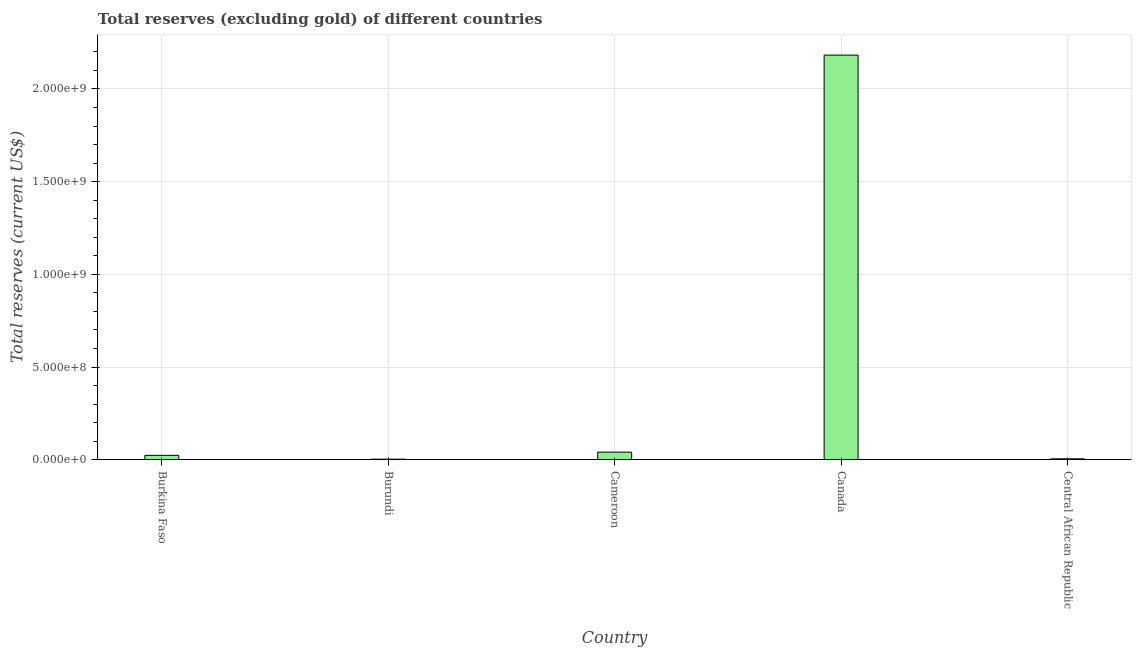Does the graph contain any zero values?
Your response must be concise. No. Does the graph contain grids?
Make the answer very short. Yes. What is the title of the graph?
Your response must be concise. Total reserves (excluding gold) of different countries. What is the label or title of the X-axis?
Offer a very short reply. Country. What is the label or title of the Y-axis?
Ensure brevity in your answer.  Total reserves (current US$). What is the total reserves (excluding gold) in Central African Republic?
Provide a short and direct response. 4.70e+06. Across all countries, what is the maximum total reserves (excluding gold)?
Provide a short and direct response. 2.18e+09. Across all countries, what is the minimum total reserves (excluding gold)?
Keep it short and to the point. 2.91e+06. In which country was the total reserves (excluding gold) maximum?
Keep it short and to the point. Canada. In which country was the total reserves (excluding gold) minimum?
Your answer should be compact. Burundi. What is the sum of the total reserves (excluding gold)?
Make the answer very short. 2.25e+09. What is the difference between the total reserves (excluding gold) in Burkina Faso and Canada?
Your answer should be compact. -2.16e+09. What is the average total reserves (excluding gold) per country?
Ensure brevity in your answer.  4.51e+08. What is the median total reserves (excluding gold)?
Offer a very short reply. 2.34e+07. In how many countries, is the total reserves (excluding gold) greater than 2100000000 US$?
Provide a succinct answer. 1. What is the ratio of the total reserves (excluding gold) in Burkina Faso to that in Burundi?
Your response must be concise. 8.05. Is the total reserves (excluding gold) in Cameroon less than that in Central African Republic?
Provide a short and direct response. No. What is the difference between the highest and the second highest total reserves (excluding gold)?
Make the answer very short. 2.14e+09. Is the sum of the total reserves (excluding gold) in Cameroon and Central African Republic greater than the maximum total reserves (excluding gold) across all countries?
Ensure brevity in your answer.  No. What is the difference between the highest and the lowest total reserves (excluding gold)?
Ensure brevity in your answer.  2.18e+09. What is the difference between two consecutive major ticks on the Y-axis?
Ensure brevity in your answer.  5.00e+08. What is the Total reserves (current US$) of Burkina Faso?
Ensure brevity in your answer.  2.34e+07. What is the Total reserves (current US$) in Burundi?
Offer a very short reply. 2.91e+06. What is the Total reserves (current US$) in Cameroon?
Keep it short and to the point. 4.09e+07. What is the Total reserves (current US$) in Canada?
Your response must be concise. 2.18e+09. What is the Total reserves (current US$) of Central African Republic?
Make the answer very short. 4.70e+06. What is the difference between the Total reserves (current US$) in Burkina Faso and Burundi?
Keep it short and to the point. 2.05e+07. What is the difference between the Total reserves (current US$) in Burkina Faso and Cameroon?
Keep it short and to the point. -1.74e+07. What is the difference between the Total reserves (current US$) in Burkina Faso and Canada?
Your answer should be very brief. -2.16e+09. What is the difference between the Total reserves (current US$) in Burkina Faso and Central African Republic?
Your answer should be very brief. 1.87e+07. What is the difference between the Total reserves (current US$) in Burundi and Cameroon?
Provide a succinct answer. -3.79e+07. What is the difference between the Total reserves (current US$) in Burundi and Canada?
Your response must be concise. -2.18e+09. What is the difference between the Total reserves (current US$) in Burundi and Central African Republic?
Provide a short and direct response. -1.79e+06. What is the difference between the Total reserves (current US$) in Cameroon and Canada?
Give a very brief answer. -2.14e+09. What is the difference between the Total reserves (current US$) in Cameroon and Central African Republic?
Your answer should be compact. 3.62e+07. What is the difference between the Total reserves (current US$) in Canada and Central African Republic?
Your answer should be compact. 2.18e+09. What is the ratio of the Total reserves (current US$) in Burkina Faso to that in Burundi?
Your response must be concise. 8.05. What is the ratio of the Total reserves (current US$) in Burkina Faso to that in Cameroon?
Provide a succinct answer. 0.57. What is the ratio of the Total reserves (current US$) in Burkina Faso to that in Canada?
Make the answer very short. 0.01. What is the ratio of the Total reserves (current US$) in Burkina Faso to that in Central African Republic?
Provide a short and direct response. 4.99. What is the ratio of the Total reserves (current US$) in Burundi to that in Cameroon?
Give a very brief answer. 0.07. What is the ratio of the Total reserves (current US$) in Burundi to that in Canada?
Your answer should be compact. 0. What is the ratio of the Total reserves (current US$) in Burundi to that in Central African Republic?
Keep it short and to the point. 0.62. What is the ratio of the Total reserves (current US$) in Cameroon to that in Canada?
Ensure brevity in your answer.  0.02. What is the ratio of the Total reserves (current US$) in Cameroon to that in Central African Republic?
Provide a short and direct response. 8.7. What is the ratio of the Total reserves (current US$) in Canada to that in Central African Republic?
Provide a short and direct response. 464.68. 